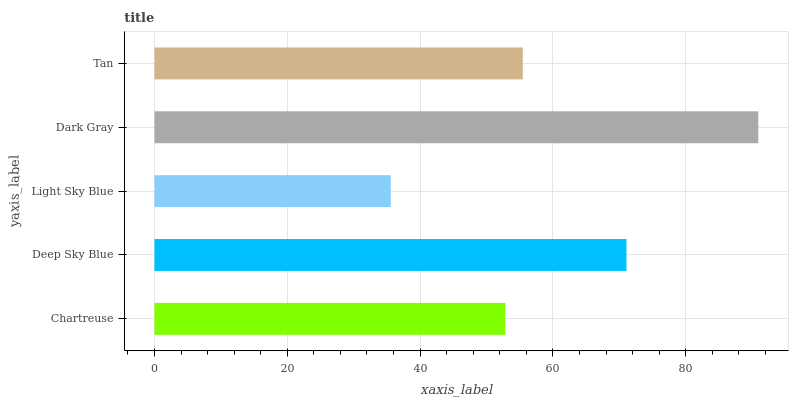Is Light Sky Blue the minimum?
Answer yes or no. Yes. Is Dark Gray the maximum?
Answer yes or no. Yes. Is Deep Sky Blue the minimum?
Answer yes or no. No. Is Deep Sky Blue the maximum?
Answer yes or no. No. Is Deep Sky Blue greater than Chartreuse?
Answer yes or no. Yes. Is Chartreuse less than Deep Sky Blue?
Answer yes or no. Yes. Is Chartreuse greater than Deep Sky Blue?
Answer yes or no. No. Is Deep Sky Blue less than Chartreuse?
Answer yes or no. No. Is Tan the high median?
Answer yes or no. Yes. Is Tan the low median?
Answer yes or no. Yes. Is Chartreuse the high median?
Answer yes or no. No. Is Dark Gray the low median?
Answer yes or no. No. 